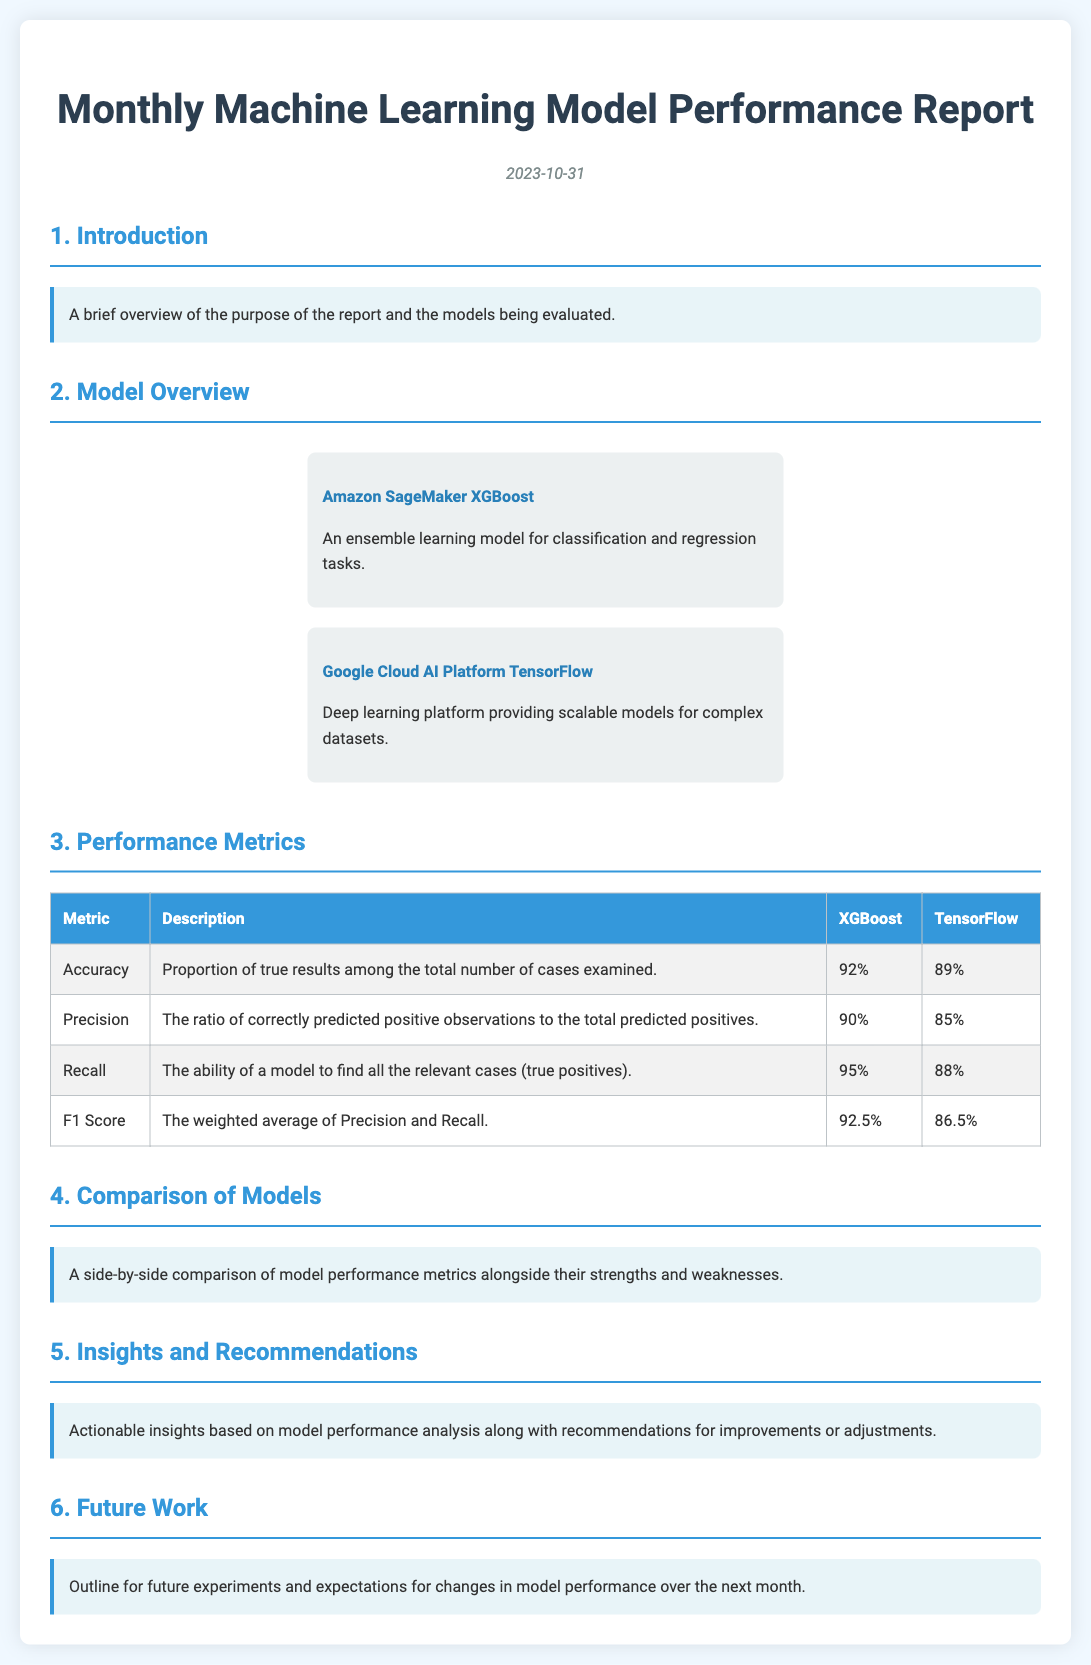What is the date of the report? The date of the report is mentioned at the top, which is 2023-10-31.
Answer: 2023-10-31 What is the accuracy of the XGBoost model? The accuracy of the XGBoost model is provided in the performance metrics table.
Answer: 92% Which model has a higher precision? The model with the higher precision can be determined by comparing the precision values in the metrics table.
Answer: XGBoost What is the F1 Score of TensorFlow? The F1 Score for TensorFlow is listed in the performance metrics table.
Answer: 86.5% What is the primary purpose of the report? The purpose of the report is described in the introduction section as providing an overview of the evaluated models.
Answer: Overview of the purpose of the report and the models being evaluated Which model has the highest recall value? The model with the highest recall can be identified from the recall values listed in the performance metrics table.
Answer: XGBoost What section follows the "Comparison of Models"? The section that follows is detailed in the document's structure, indicating the next focus area after comparisons.
Answer: Insights and Recommendations What is mentioned as part of future work? Future expectations or experiments are discussed in the future work section, focusing on anticipated changes.
Answer: Outline for future experiments and expectations for changes in model performance over the next month 